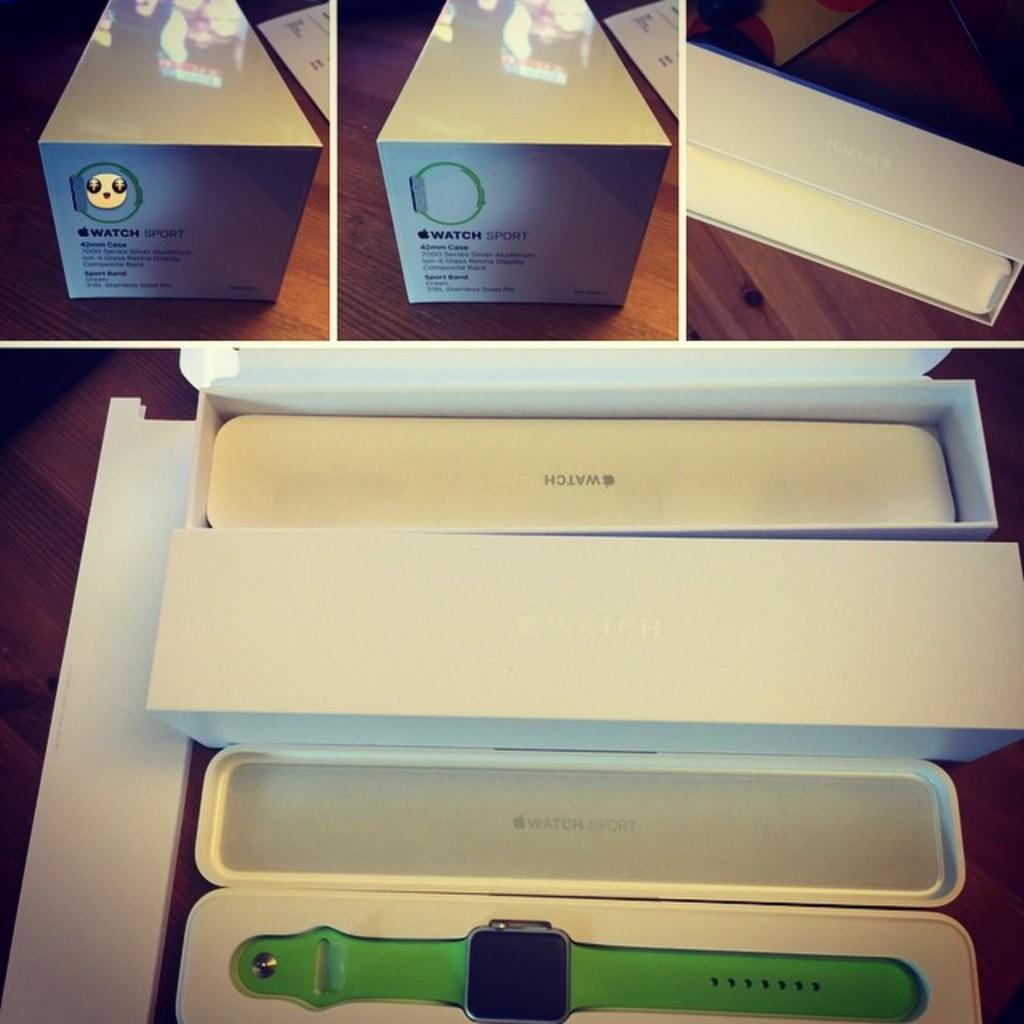<image>
Give a short and clear explanation of the subsequent image. Apple Watch Sport is branded onto this packaging. 